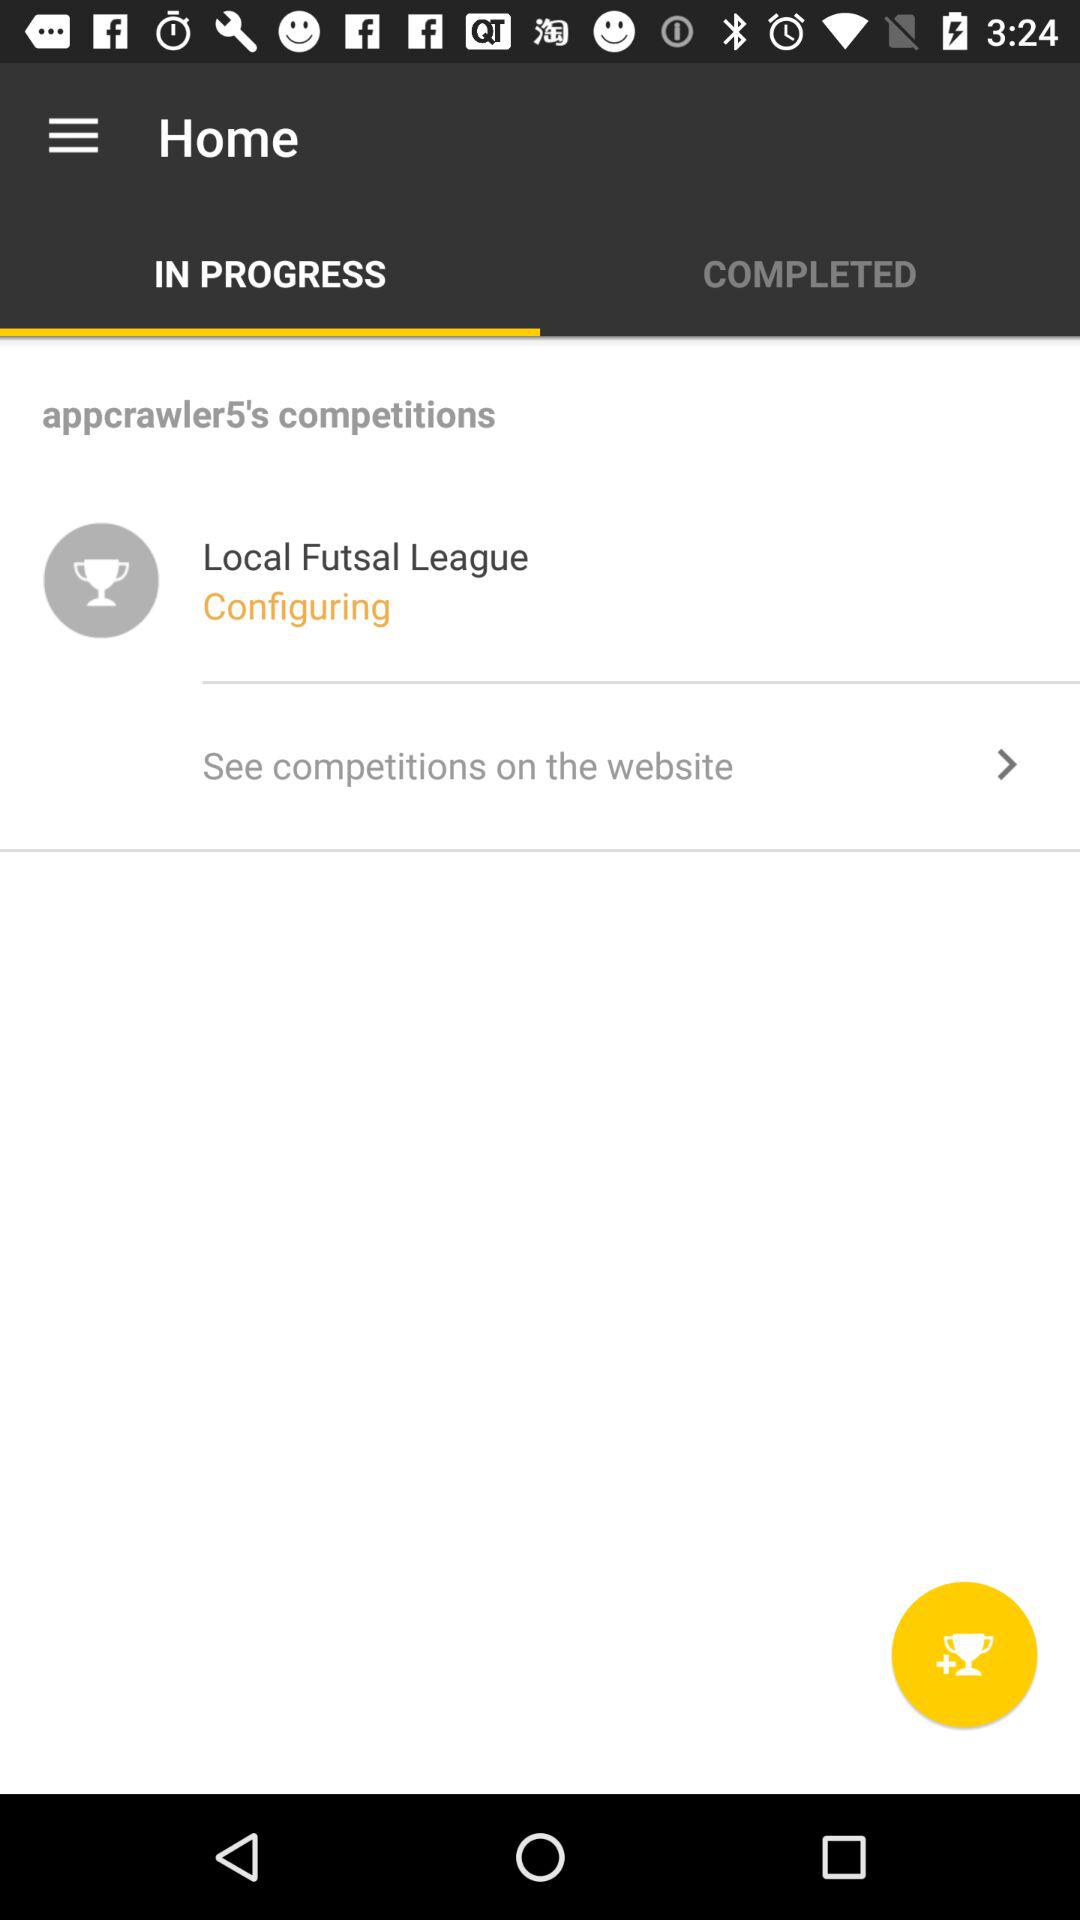How many have been completed?
When the provided information is insufficient, respond with <no answer>. <no answer> 